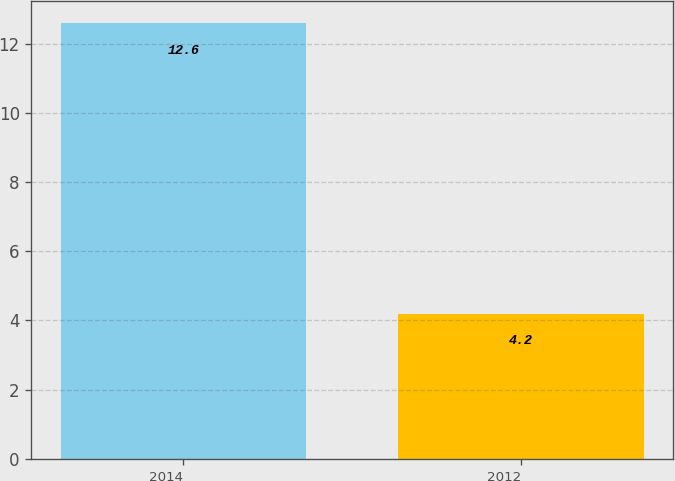Convert chart to OTSL. <chart><loc_0><loc_0><loc_500><loc_500><bar_chart><fcel>2014<fcel>2012<nl><fcel>12.6<fcel>4.2<nl></chart> 